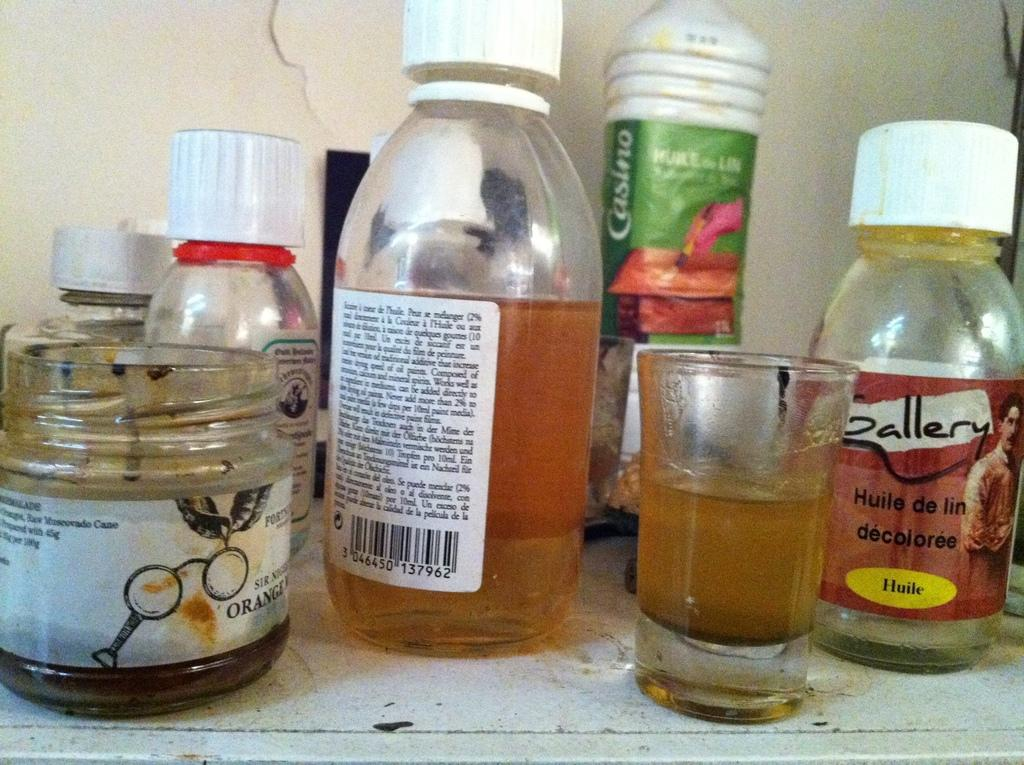Provide a one-sentence caption for the provided image. some bottles for Gallery Huile de lin Decoloree and and jars on a table. 